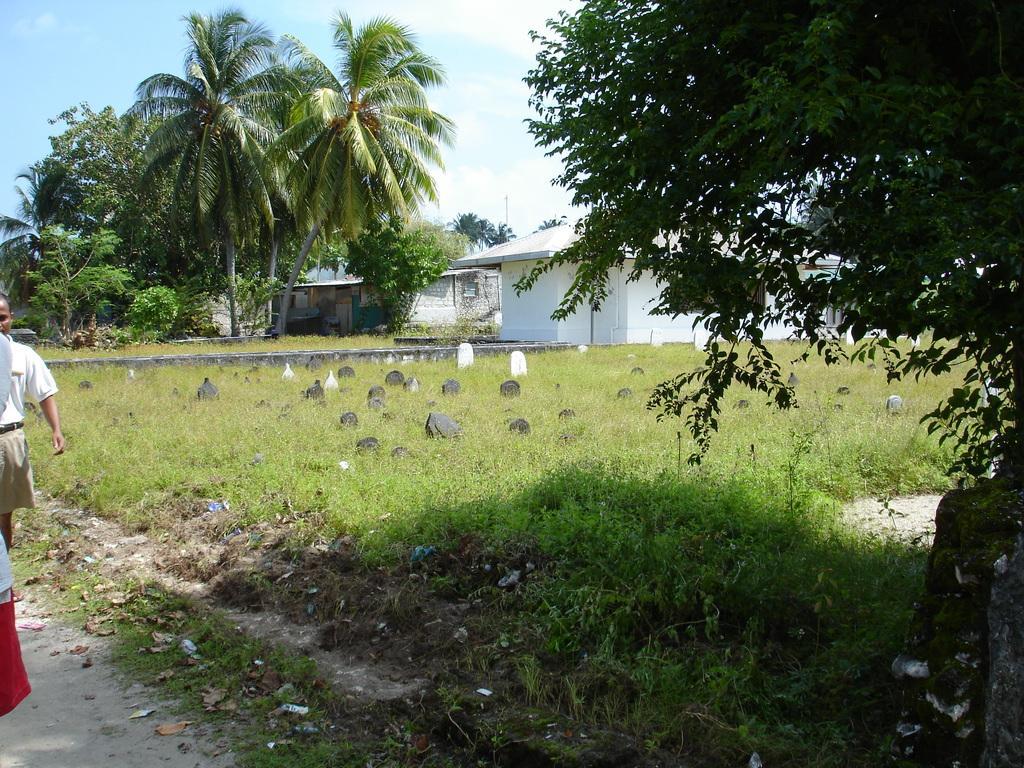How would you summarize this image in a sentence or two? This picture is clicked outside. On the left corner there is a person seems to be walking on the ground. In the center we can see the plants, green grass and trees. There are some objects on the ground. In the background there is a sky, trees and the buildings. 